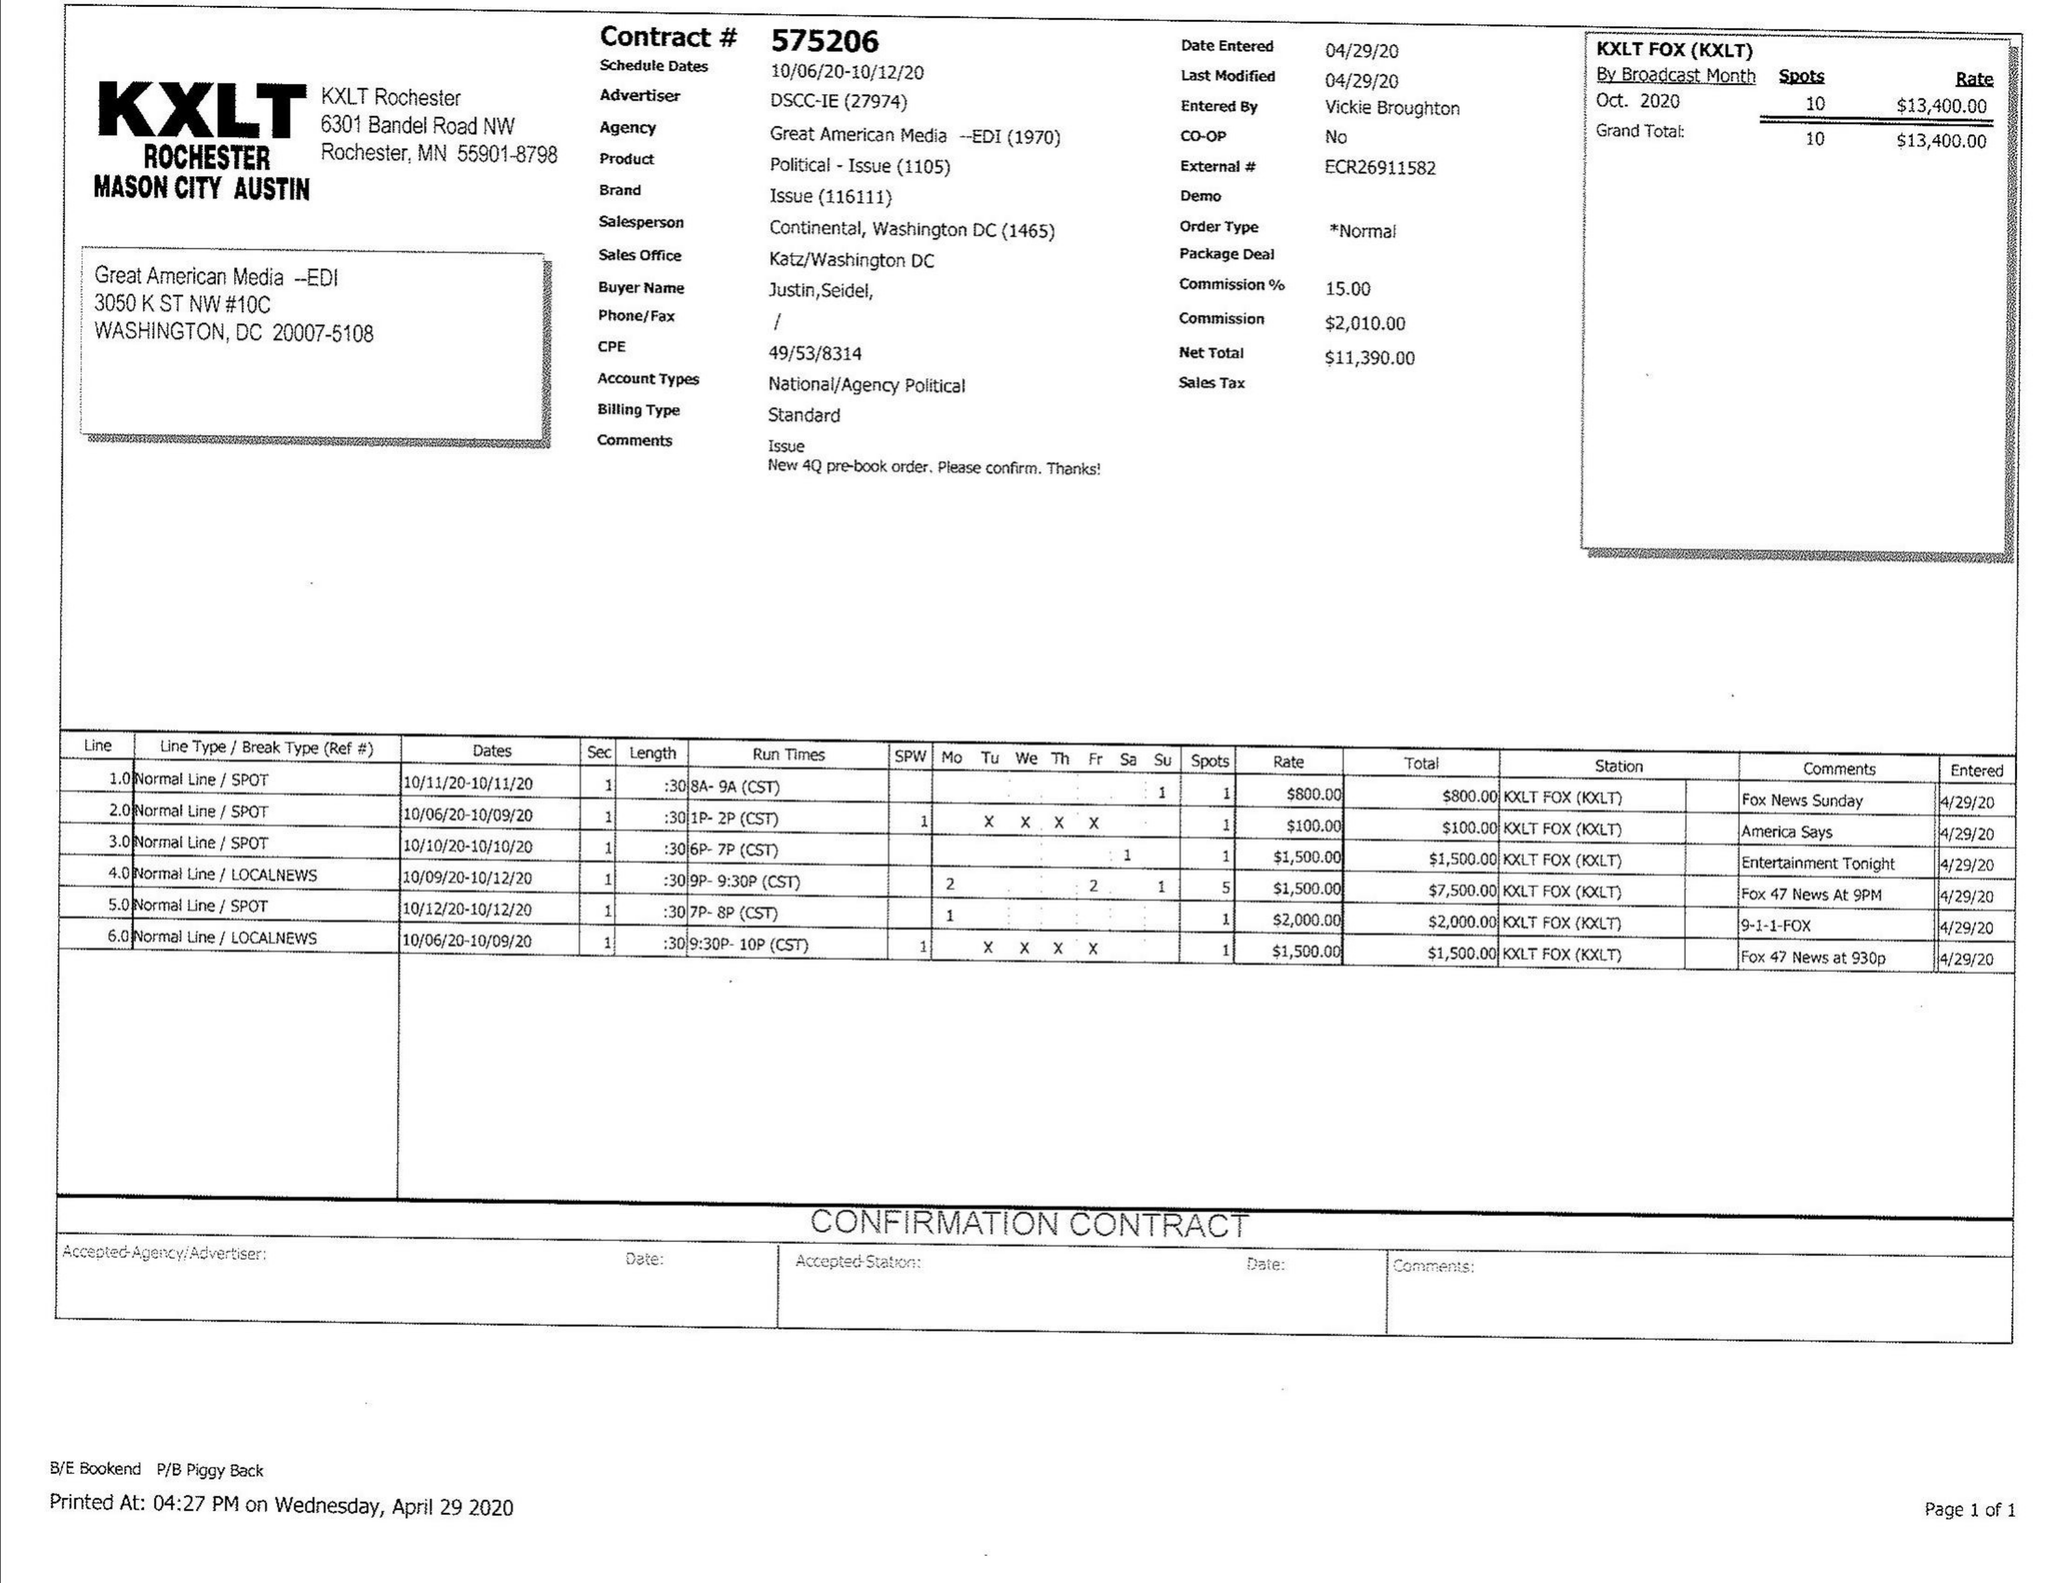What is the value for the flight_to?
Answer the question using a single word or phrase. 10/12/20 